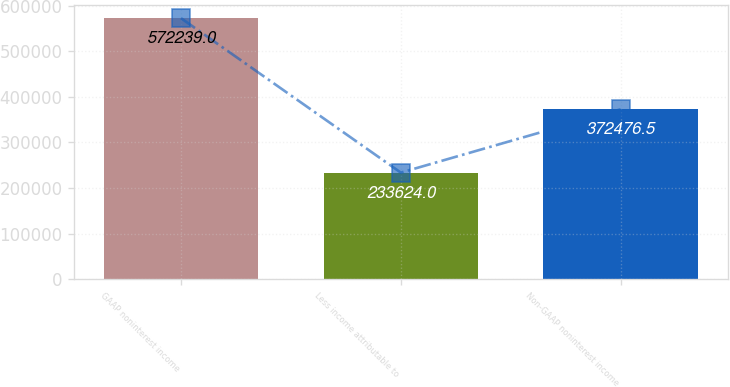<chart> <loc_0><loc_0><loc_500><loc_500><bar_chart><fcel>GAAP noninterest income<fcel>Less income attributable to<fcel>Non-GAAP noninterest income<nl><fcel>572239<fcel>233624<fcel>372476<nl></chart> 